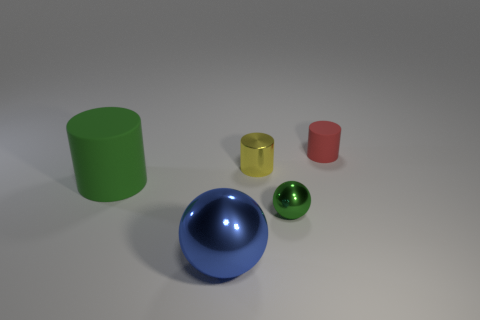Add 1 tiny green balls. How many objects exist? 6 Subtract all red rubber cylinders. How many cylinders are left? 2 Subtract all yellow cylinders. How many cylinders are left? 2 Subtract all green balls. Subtract all brown blocks. How many balls are left? 1 Subtract all cyan cylinders. How many red spheres are left? 0 Subtract all small red objects. Subtract all large green matte things. How many objects are left? 3 Add 1 red cylinders. How many red cylinders are left? 2 Add 2 red matte cylinders. How many red matte cylinders exist? 3 Subtract 0 purple balls. How many objects are left? 5 Subtract all spheres. How many objects are left? 3 